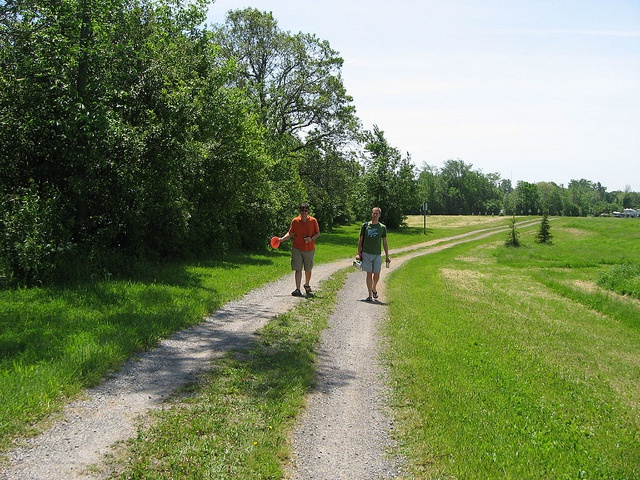Describe the objects in this image and their specific colors. I can see people in lightblue, maroon, gray, and black tones, people in lightblue, black, gray, and maroon tones, frisbee in lightblue, red, brown, and maroon tones, and cup in lightblue, gray, and darkgreen tones in this image. 